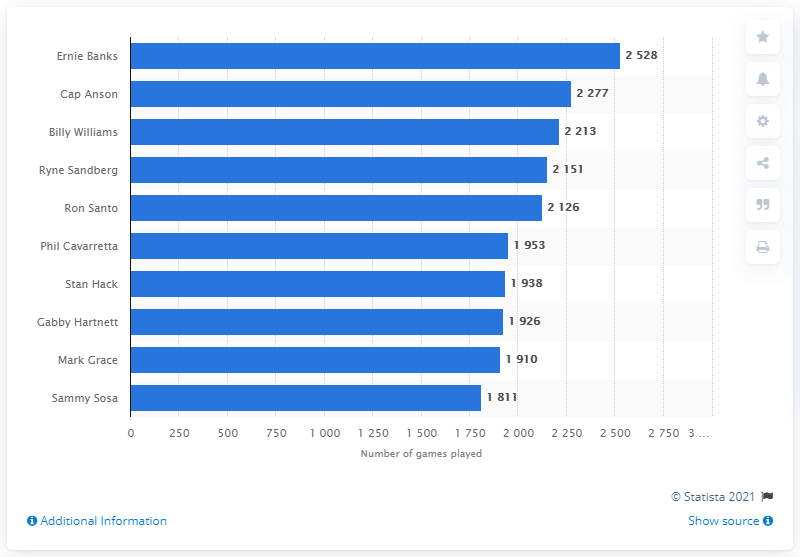Specify some key components in this picture. What is the value for Ron Santo? It is 2126. The average between the top and bottom bars is 2169. Ernie Banks, the Cubs franchise player, has played the most games in history. 